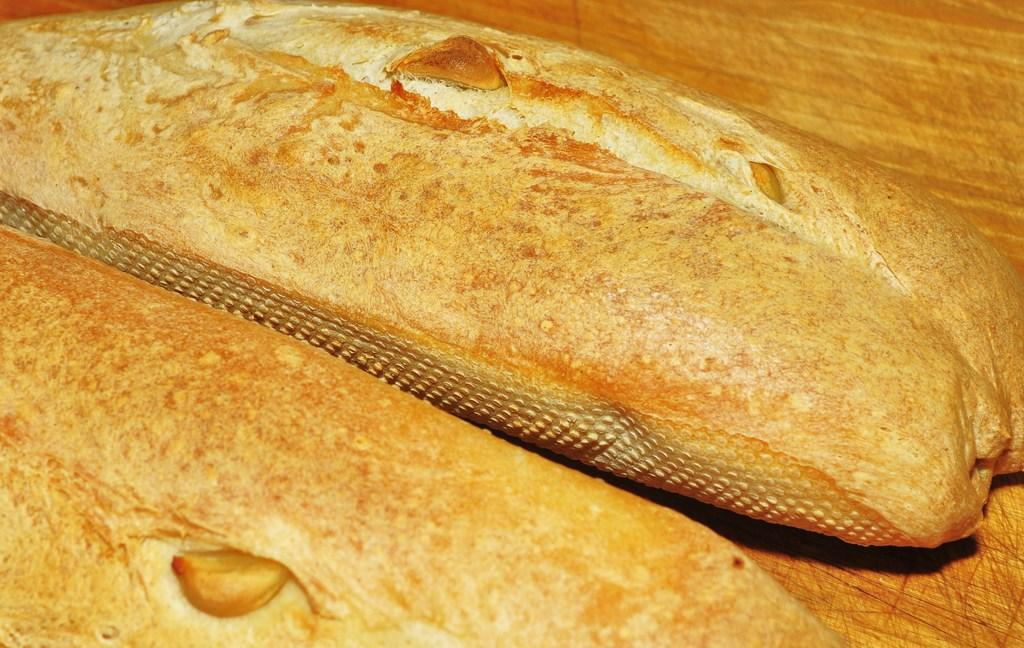What type of bread is shown in the image? There are two sourdoughs in the image. Where are the sourdoughs located? The sourdoughs are placed on a table. What color are the sourdoughs? The sourdoughdoughs are in cream color. What type of animal can be seen interacting with the sourdoughs in the image? There are no animals present in the image; it only features sourdoughs on a table. 